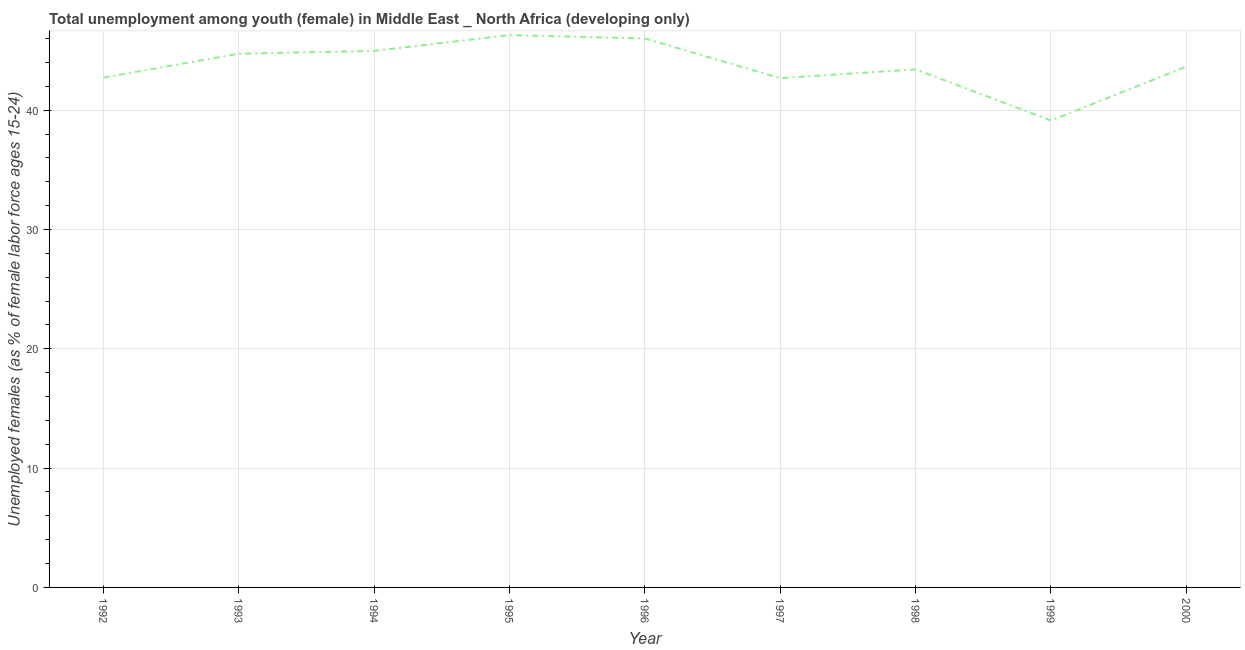What is the unemployed female youth population in 2000?
Your response must be concise. 43.66. Across all years, what is the maximum unemployed female youth population?
Your response must be concise. 46.3. Across all years, what is the minimum unemployed female youth population?
Your answer should be compact. 39.14. In which year was the unemployed female youth population maximum?
Provide a short and direct response. 1995. In which year was the unemployed female youth population minimum?
Provide a succinct answer. 1999. What is the sum of the unemployed female youth population?
Make the answer very short. 393.69. What is the difference between the unemployed female youth population in 1997 and 1999?
Your answer should be very brief. 3.55. What is the average unemployed female youth population per year?
Give a very brief answer. 43.74. What is the median unemployed female youth population?
Your answer should be very brief. 43.66. In how many years, is the unemployed female youth population greater than 4 %?
Ensure brevity in your answer.  9. Do a majority of the years between 1993 and 2000 (inclusive) have unemployed female youth population greater than 6 %?
Ensure brevity in your answer.  Yes. What is the ratio of the unemployed female youth population in 1992 to that in 1998?
Offer a terse response. 0.98. What is the difference between the highest and the second highest unemployed female youth population?
Provide a short and direct response. 0.28. Is the sum of the unemployed female youth population in 1994 and 1996 greater than the maximum unemployed female youth population across all years?
Your response must be concise. Yes. What is the difference between the highest and the lowest unemployed female youth population?
Offer a very short reply. 7.16. Does the unemployed female youth population monotonically increase over the years?
Offer a terse response. No. How many lines are there?
Provide a succinct answer. 1. Does the graph contain any zero values?
Your response must be concise. No. Does the graph contain grids?
Offer a very short reply. Yes. What is the title of the graph?
Provide a succinct answer. Total unemployment among youth (female) in Middle East _ North Africa (developing only). What is the label or title of the Y-axis?
Ensure brevity in your answer.  Unemployed females (as % of female labor force ages 15-24). What is the Unemployed females (as % of female labor force ages 15-24) of 1992?
Offer a very short reply. 42.73. What is the Unemployed females (as % of female labor force ages 15-24) of 1993?
Make the answer very short. 44.74. What is the Unemployed females (as % of female labor force ages 15-24) in 1994?
Offer a very short reply. 44.98. What is the Unemployed females (as % of female labor force ages 15-24) of 1995?
Your response must be concise. 46.3. What is the Unemployed females (as % of female labor force ages 15-24) of 1996?
Keep it short and to the point. 46.02. What is the Unemployed females (as % of female labor force ages 15-24) in 1997?
Provide a short and direct response. 42.69. What is the Unemployed females (as % of female labor force ages 15-24) in 1998?
Provide a short and direct response. 43.43. What is the Unemployed females (as % of female labor force ages 15-24) of 1999?
Provide a short and direct response. 39.14. What is the Unemployed females (as % of female labor force ages 15-24) of 2000?
Ensure brevity in your answer.  43.66. What is the difference between the Unemployed females (as % of female labor force ages 15-24) in 1992 and 1993?
Keep it short and to the point. -2.01. What is the difference between the Unemployed females (as % of female labor force ages 15-24) in 1992 and 1994?
Provide a succinct answer. -2.24. What is the difference between the Unemployed females (as % of female labor force ages 15-24) in 1992 and 1995?
Ensure brevity in your answer.  -3.57. What is the difference between the Unemployed females (as % of female labor force ages 15-24) in 1992 and 1996?
Give a very brief answer. -3.29. What is the difference between the Unemployed females (as % of female labor force ages 15-24) in 1992 and 1997?
Keep it short and to the point. 0.04. What is the difference between the Unemployed females (as % of female labor force ages 15-24) in 1992 and 1998?
Ensure brevity in your answer.  -0.69. What is the difference between the Unemployed females (as % of female labor force ages 15-24) in 1992 and 1999?
Your answer should be compact. 3.6. What is the difference between the Unemployed females (as % of female labor force ages 15-24) in 1992 and 2000?
Offer a terse response. -0.93. What is the difference between the Unemployed females (as % of female labor force ages 15-24) in 1993 and 1994?
Provide a succinct answer. -0.24. What is the difference between the Unemployed females (as % of female labor force ages 15-24) in 1993 and 1995?
Give a very brief answer. -1.56. What is the difference between the Unemployed females (as % of female labor force ages 15-24) in 1993 and 1996?
Keep it short and to the point. -1.28. What is the difference between the Unemployed females (as % of female labor force ages 15-24) in 1993 and 1997?
Keep it short and to the point. 2.05. What is the difference between the Unemployed females (as % of female labor force ages 15-24) in 1993 and 1998?
Offer a very short reply. 1.31. What is the difference between the Unemployed females (as % of female labor force ages 15-24) in 1993 and 1999?
Your response must be concise. 5.6. What is the difference between the Unemployed females (as % of female labor force ages 15-24) in 1993 and 2000?
Ensure brevity in your answer.  1.08. What is the difference between the Unemployed females (as % of female labor force ages 15-24) in 1994 and 1995?
Ensure brevity in your answer.  -1.32. What is the difference between the Unemployed females (as % of female labor force ages 15-24) in 1994 and 1996?
Your response must be concise. -1.04. What is the difference between the Unemployed females (as % of female labor force ages 15-24) in 1994 and 1997?
Your answer should be very brief. 2.29. What is the difference between the Unemployed females (as % of female labor force ages 15-24) in 1994 and 1998?
Provide a short and direct response. 1.55. What is the difference between the Unemployed females (as % of female labor force ages 15-24) in 1994 and 1999?
Ensure brevity in your answer.  5.84. What is the difference between the Unemployed females (as % of female labor force ages 15-24) in 1994 and 2000?
Your answer should be very brief. 1.32. What is the difference between the Unemployed females (as % of female labor force ages 15-24) in 1995 and 1996?
Ensure brevity in your answer.  0.28. What is the difference between the Unemployed females (as % of female labor force ages 15-24) in 1995 and 1997?
Your answer should be compact. 3.61. What is the difference between the Unemployed females (as % of female labor force ages 15-24) in 1995 and 1998?
Your answer should be very brief. 2.87. What is the difference between the Unemployed females (as % of female labor force ages 15-24) in 1995 and 1999?
Make the answer very short. 7.16. What is the difference between the Unemployed females (as % of female labor force ages 15-24) in 1995 and 2000?
Your response must be concise. 2.64. What is the difference between the Unemployed females (as % of female labor force ages 15-24) in 1996 and 1997?
Give a very brief answer. 3.33. What is the difference between the Unemployed females (as % of female labor force ages 15-24) in 1996 and 1998?
Keep it short and to the point. 2.59. What is the difference between the Unemployed females (as % of female labor force ages 15-24) in 1996 and 1999?
Ensure brevity in your answer.  6.88. What is the difference between the Unemployed females (as % of female labor force ages 15-24) in 1996 and 2000?
Keep it short and to the point. 2.36. What is the difference between the Unemployed females (as % of female labor force ages 15-24) in 1997 and 1998?
Your answer should be compact. -0.74. What is the difference between the Unemployed females (as % of female labor force ages 15-24) in 1997 and 1999?
Offer a very short reply. 3.55. What is the difference between the Unemployed females (as % of female labor force ages 15-24) in 1997 and 2000?
Ensure brevity in your answer.  -0.97. What is the difference between the Unemployed females (as % of female labor force ages 15-24) in 1998 and 1999?
Ensure brevity in your answer.  4.29. What is the difference between the Unemployed females (as % of female labor force ages 15-24) in 1998 and 2000?
Offer a terse response. -0.24. What is the difference between the Unemployed females (as % of female labor force ages 15-24) in 1999 and 2000?
Keep it short and to the point. -4.53. What is the ratio of the Unemployed females (as % of female labor force ages 15-24) in 1992 to that in 1993?
Your response must be concise. 0.95. What is the ratio of the Unemployed females (as % of female labor force ages 15-24) in 1992 to that in 1994?
Make the answer very short. 0.95. What is the ratio of the Unemployed females (as % of female labor force ages 15-24) in 1992 to that in 1995?
Keep it short and to the point. 0.92. What is the ratio of the Unemployed females (as % of female labor force ages 15-24) in 1992 to that in 1996?
Provide a short and direct response. 0.93. What is the ratio of the Unemployed females (as % of female labor force ages 15-24) in 1992 to that in 1997?
Keep it short and to the point. 1. What is the ratio of the Unemployed females (as % of female labor force ages 15-24) in 1992 to that in 1998?
Keep it short and to the point. 0.98. What is the ratio of the Unemployed females (as % of female labor force ages 15-24) in 1992 to that in 1999?
Ensure brevity in your answer.  1.09. What is the ratio of the Unemployed females (as % of female labor force ages 15-24) in 1992 to that in 2000?
Provide a short and direct response. 0.98. What is the ratio of the Unemployed females (as % of female labor force ages 15-24) in 1993 to that in 1996?
Give a very brief answer. 0.97. What is the ratio of the Unemployed females (as % of female labor force ages 15-24) in 1993 to that in 1997?
Provide a short and direct response. 1.05. What is the ratio of the Unemployed females (as % of female labor force ages 15-24) in 1993 to that in 1998?
Make the answer very short. 1.03. What is the ratio of the Unemployed females (as % of female labor force ages 15-24) in 1993 to that in 1999?
Give a very brief answer. 1.14. What is the ratio of the Unemployed females (as % of female labor force ages 15-24) in 1994 to that in 1995?
Provide a succinct answer. 0.97. What is the ratio of the Unemployed females (as % of female labor force ages 15-24) in 1994 to that in 1997?
Keep it short and to the point. 1.05. What is the ratio of the Unemployed females (as % of female labor force ages 15-24) in 1994 to that in 1998?
Provide a short and direct response. 1.04. What is the ratio of the Unemployed females (as % of female labor force ages 15-24) in 1994 to that in 1999?
Your answer should be compact. 1.15. What is the ratio of the Unemployed females (as % of female labor force ages 15-24) in 1995 to that in 1996?
Keep it short and to the point. 1.01. What is the ratio of the Unemployed females (as % of female labor force ages 15-24) in 1995 to that in 1997?
Provide a short and direct response. 1.08. What is the ratio of the Unemployed females (as % of female labor force ages 15-24) in 1995 to that in 1998?
Offer a terse response. 1.07. What is the ratio of the Unemployed females (as % of female labor force ages 15-24) in 1995 to that in 1999?
Your answer should be very brief. 1.18. What is the ratio of the Unemployed females (as % of female labor force ages 15-24) in 1995 to that in 2000?
Your answer should be very brief. 1.06. What is the ratio of the Unemployed females (as % of female labor force ages 15-24) in 1996 to that in 1997?
Give a very brief answer. 1.08. What is the ratio of the Unemployed females (as % of female labor force ages 15-24) in 1996 to that in 1998?
Your answer should be very brief. 1.06. What is the ratio of the Unemployed females (as % of female labor force ages 15-24) in 1996 to that in 1999?
Keep it short and to the point. 1.18. What is the ratio of the Unemployed females (as % of female labor force ages 15-24) in 1996 to that in 2000?
Your answer should be very brief. 1.05. What is the ratio of the Unemployed females (as % of female labor force ages 15-24) in 1997 to that in 1998?
Make the answer very short. 0.98. What is the ratio of the Unemployed females (as % of female labor force ages 15-24) in 1997 to that in 1999?
Offer a very short reply. 1.09. What is the ratio of the Unemployed females (as % of female labor force ages 15-24) in 1998 to that in 1999?
Your answer should be very brief. 1.11. What is the ratio of the Unemployed females (as % of female labor force ages 15-24) in 1998 to that in 2000?
Offer a very short reply. 0.99. What is the ratio of the Unemployed females (as % of female labor force ages 15-24) in 1999 to that in 2000?
Make the answer very short. 0.9. 